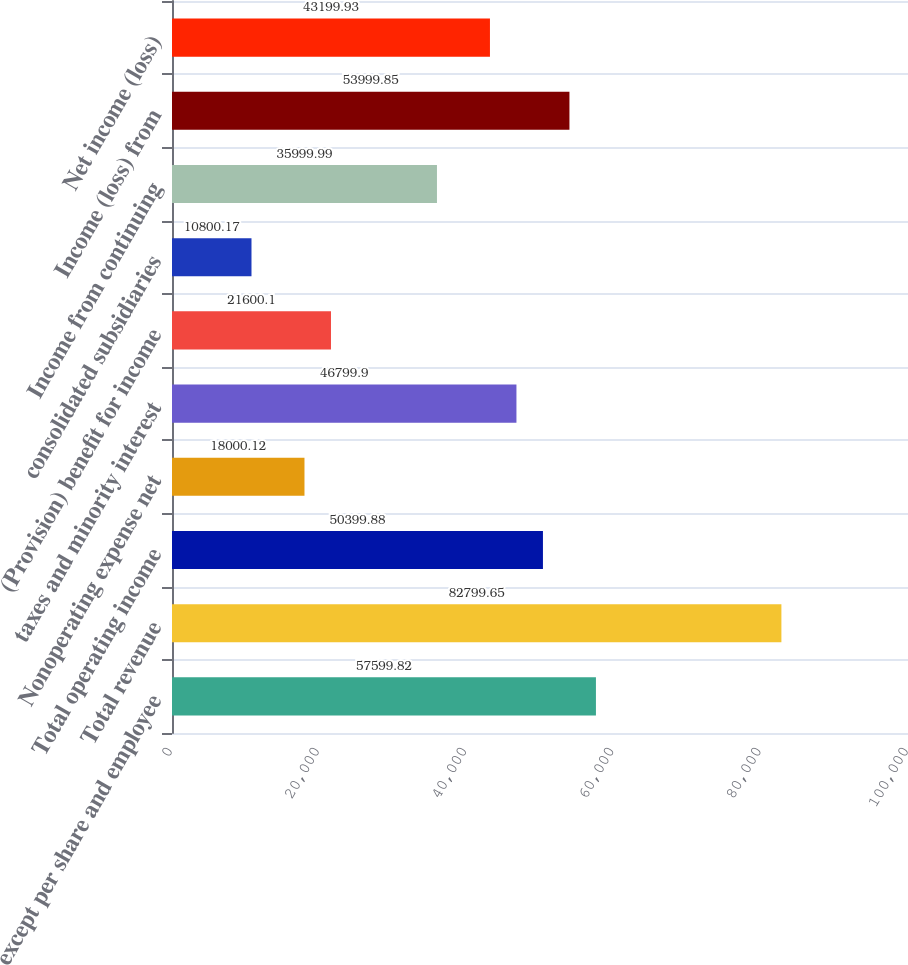Convert chart to OTSL. <chart><loc_0><loc_0><loc_500><loc_500><bar_chart><fcel>except per share and employee<fcel>Total revenue<fcel>Total operating income<fcel>Nonoperating expense net<fcel>taxes and minority interest<fcel>(Provision) benefit for income<fcel>consolidated subsidiaries<fcel>Income from continuing<fcel>Income (loss) from<fcel>Net income (loss)<nl><fcel>57599.8<fcel>82799.6<fcel>50399.9<fcel>18000.1<fcel>46799.9<fcel>21600.1<fcel>10800.2<fcel>36000<fcel>53999.8<fcel>43199.9<nl></chart> 